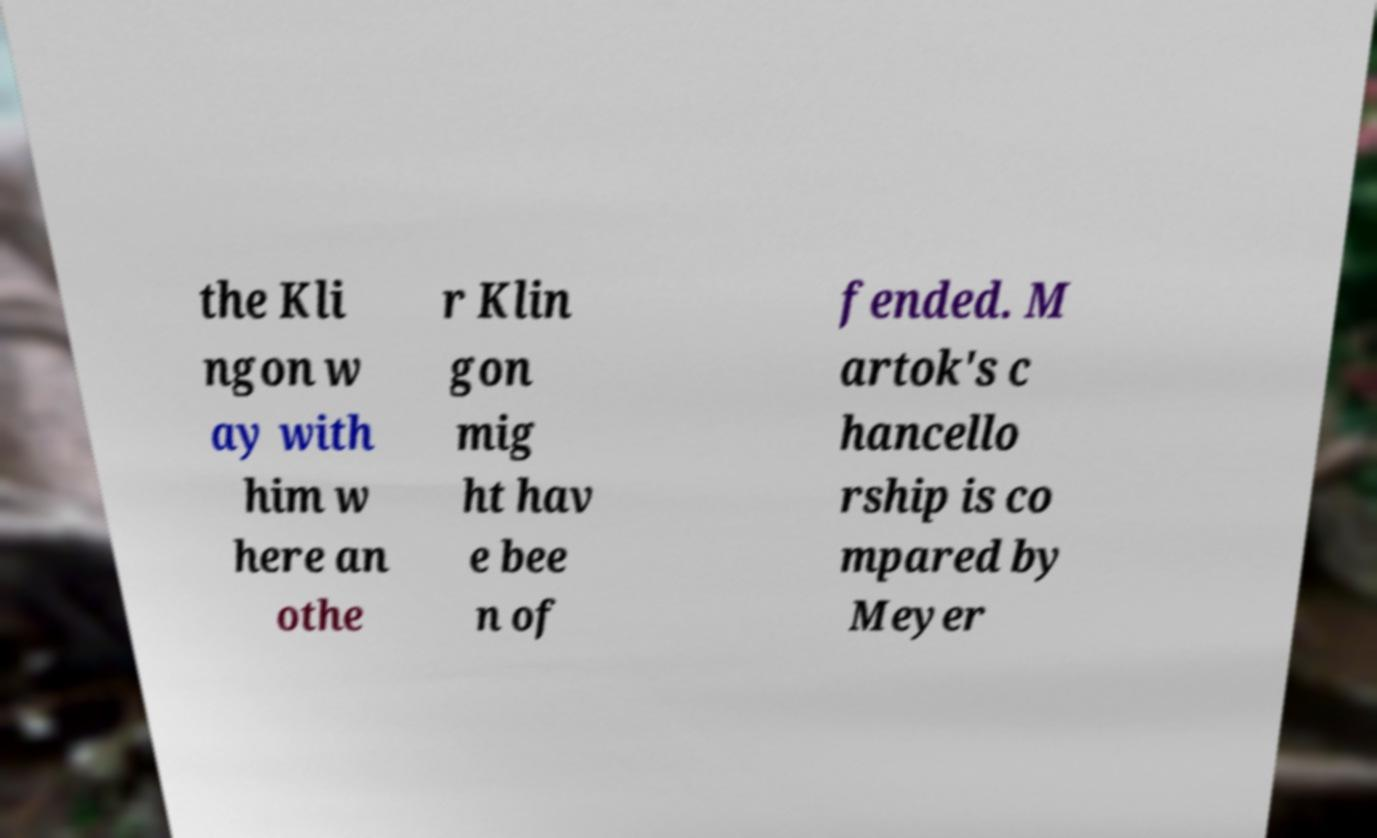Can you accurately transcribe the text from the provided image for me? the Kli ngon w ay with him w here an othe r Klin gon mig ht hav e bee n of fended. M artok's c hancello rship is co mpared by Meyer 